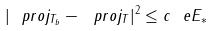<formula> <loc_0><loc_0><loc_500><loc_500>| \ p r o j _ { T _ { b } } - \ p r o j _ { T } | ^ { 2 } \leq c \ e E _ { * }</formula> 